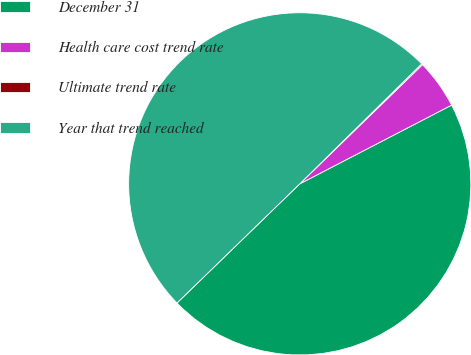Convert chart. <chart><loc_0><loc_0><loc_500><loc_500><pie_chart><fcel>December 31<fcel>Health care cost trend rate<fcel>Ultimate trend rate<fcel>Year that trend reached<nl><fcel>45.35%<fcel>4.65%<fcel>0.11%<fcel>49.89%<nl></chart> 